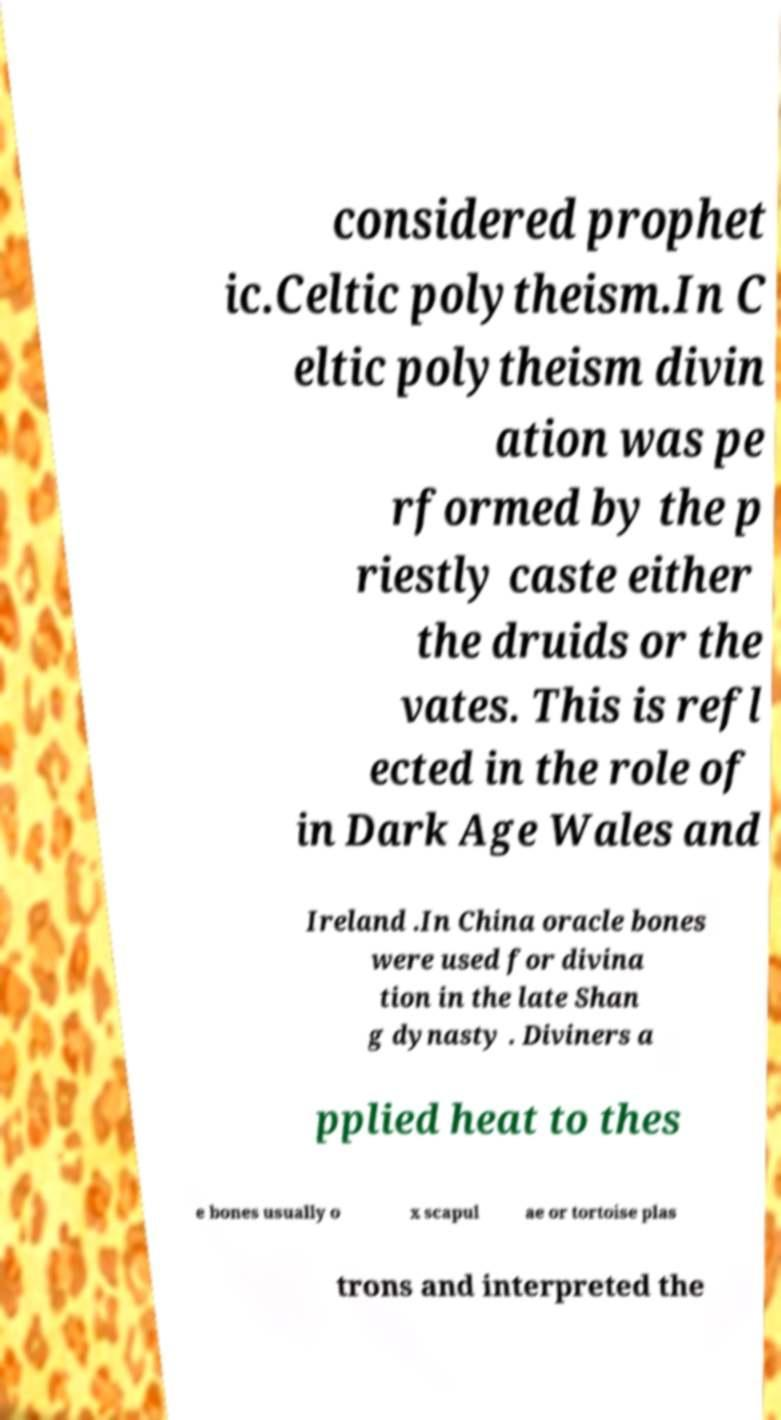There's text embedded in this image that I need extracted. Can you transcribe it verbatim? considered prophet ic.Celtic polytheism.In C eltic polytheism divin ation was pe rformed by the p riestly caste either the druids or the vates. This is refl ected in the role of in Dark Age Wales and Ireland .In China oracle bones were used for divina tion in the late Shan g dynasty . Diviners a pplied heat to thes e bones usually o x scapul ae or tortoise plas trons and interpreted the 